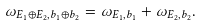<formula> <loc_0><loc_0><loc_500><loc_500>\omega _ { E _ { 1 } \oplus E _ { 2 } , b _ { 1 } \oplus b _ { 2 } } = \omega _ { E _ { 1 } , b _ { 1 } } + \omega _ { E _ { 2 } , b _ { 2 } } .</formula> 